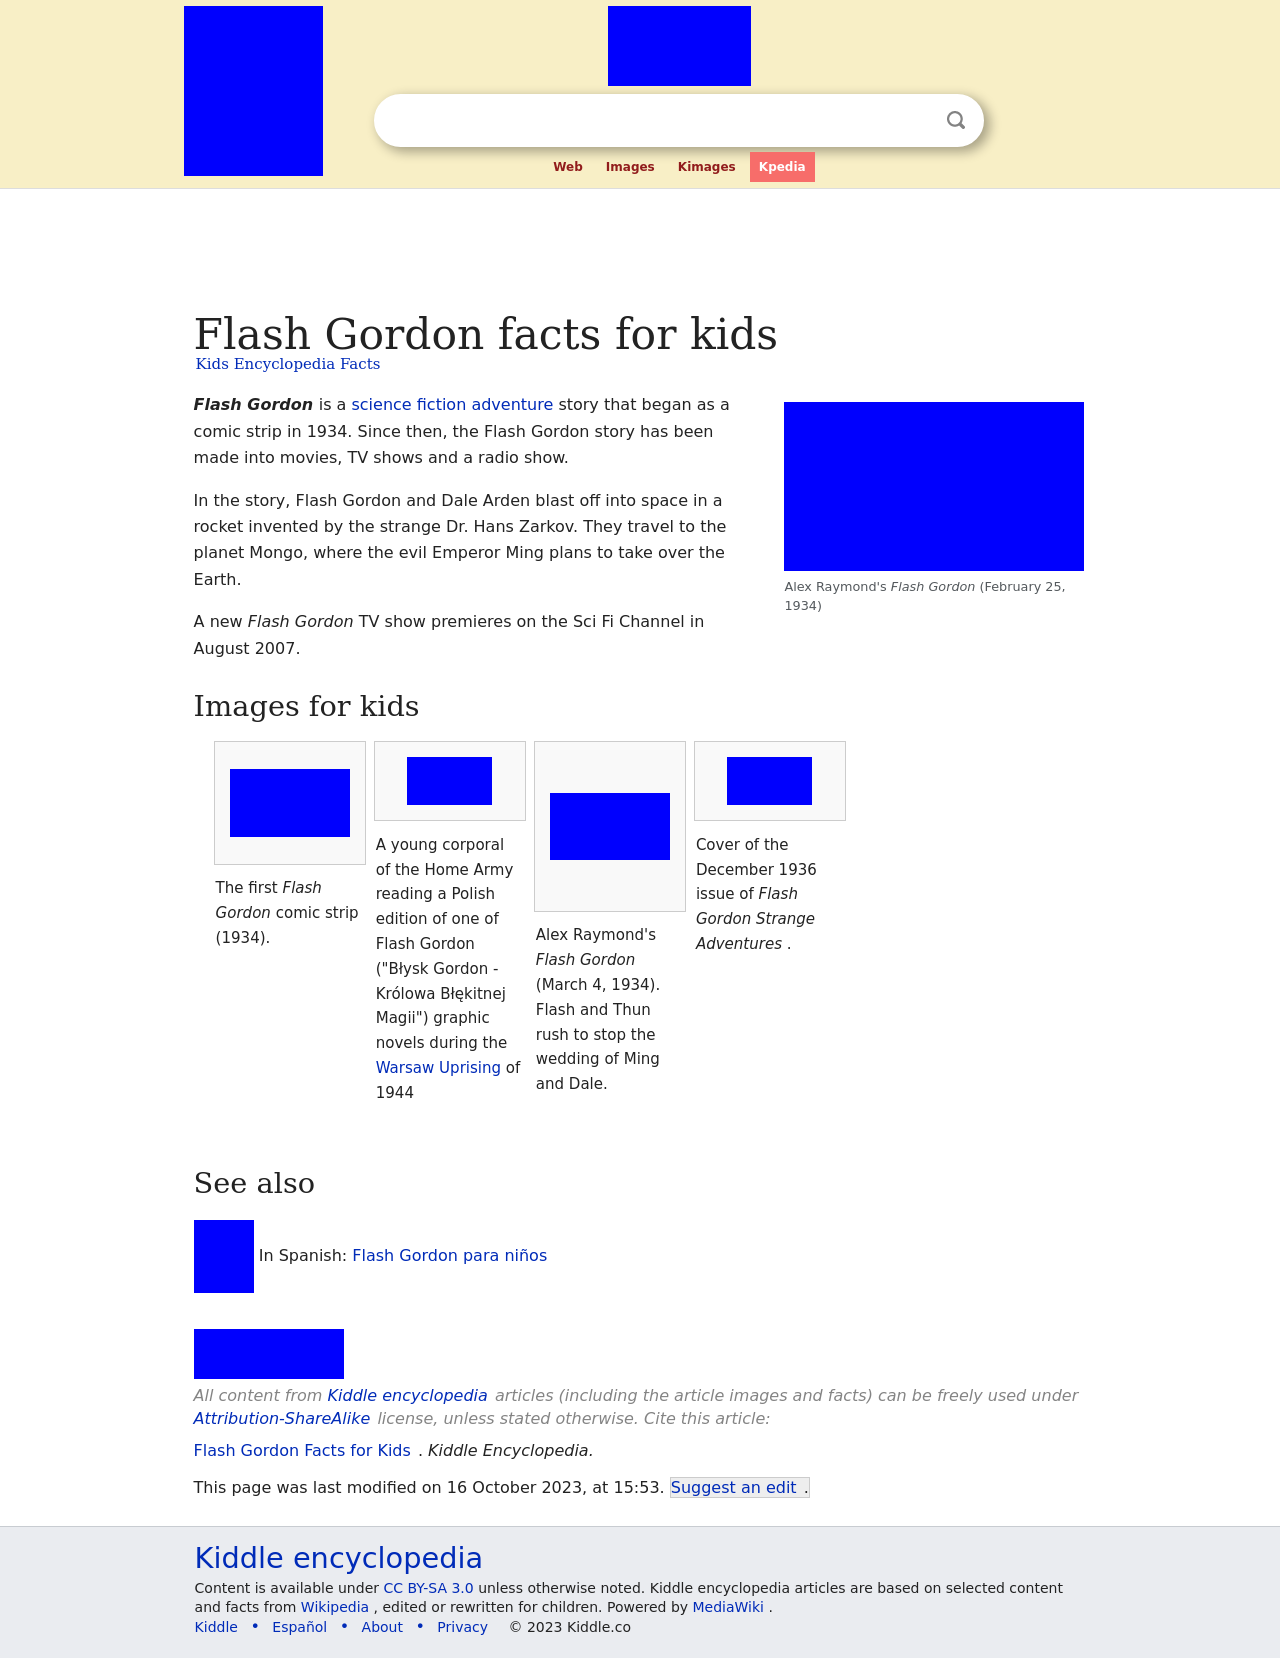What is the significance of the young corporal in the Home Army reading a Polish edition of Flash Gordon during the Warsaw Uprising? The image of a young corporal in the Home Army reading a Flash Gordon comic during the Warsaw Uprising highlights the use of popular media as a form of escape and moral support during times of conflict. This reflects how, even in dire situations, elements of popular culture like comics can provide comfort, distraction, and even inspiration against adversity. 